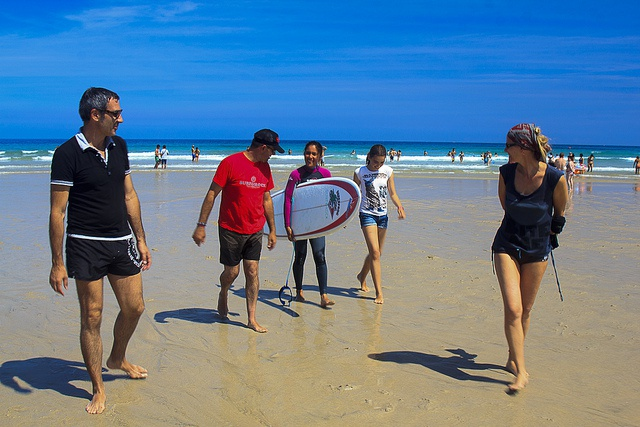Describe the objects in this image and their specific colors. I can see people in blue, black, maroon, gray, and darkgray tones, people in blue, black, maroon, and tan tones, people in blue, black, maroon, and brown tones, people in blue, darkgray, tan, black, and white tones, and surfboard in blue, gray, maroon, and darkgray tones in this image. 